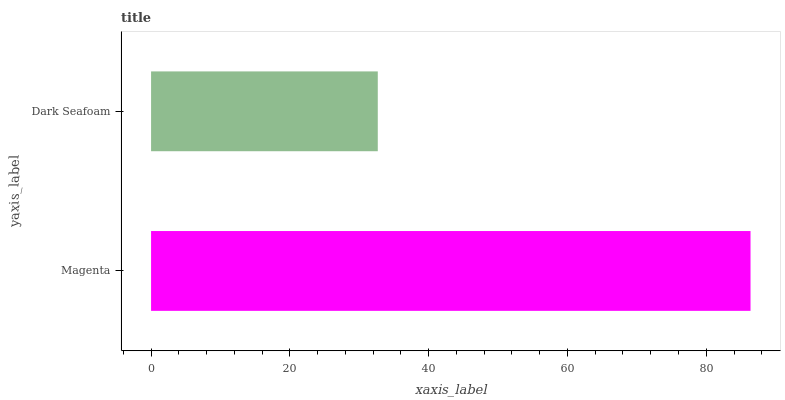Is Dark Seafoam the minimum?
Answer yes or no. Yes. Is Magenta the maximum?
Answer yes or no. Yes. Is Dark Seafoam the maximum?
Answer yes or no. No. Is Magenta greater than Dark Seafoam?
Answer yes or no. Yes. Is Dark Seafoam less than Magenta?
Answer yes or no. Yes. Is Dark Seafoam greater than Magenta?
Answer yes or no. No. Is Magenta less than Dark Seafoam?
Answer yes or no. No. Is Magenta the high median?
Answer yes or no. Yes. Is Dark Seafoam the low median?
Answer yes or no. Yes. Is Dark Seafoam the high median?
Answer yes or no. No. Is Magenta the low median?
Answer yes or no. No. 